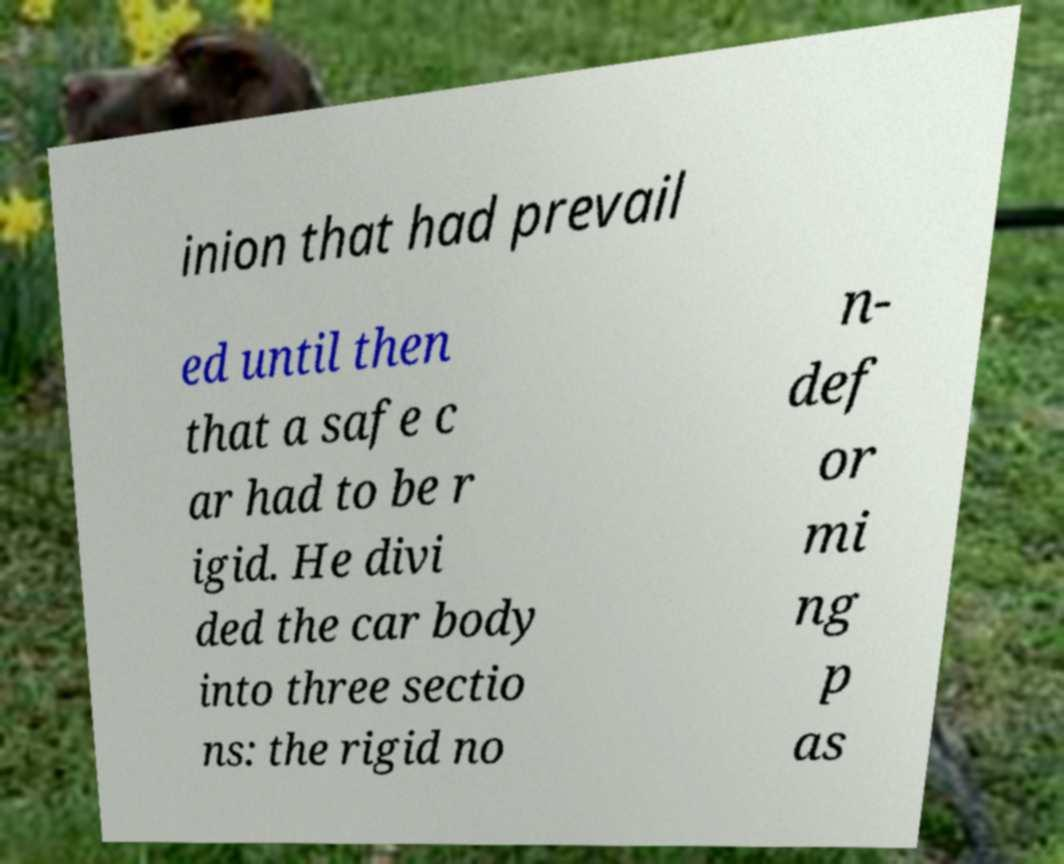Could you extract and type out the text from this image? inion that had prevail ed until then that a safe c ar had to be r igid. He divi ded the car body into three sectio ns: the rigid no n- def or mi ng p as 